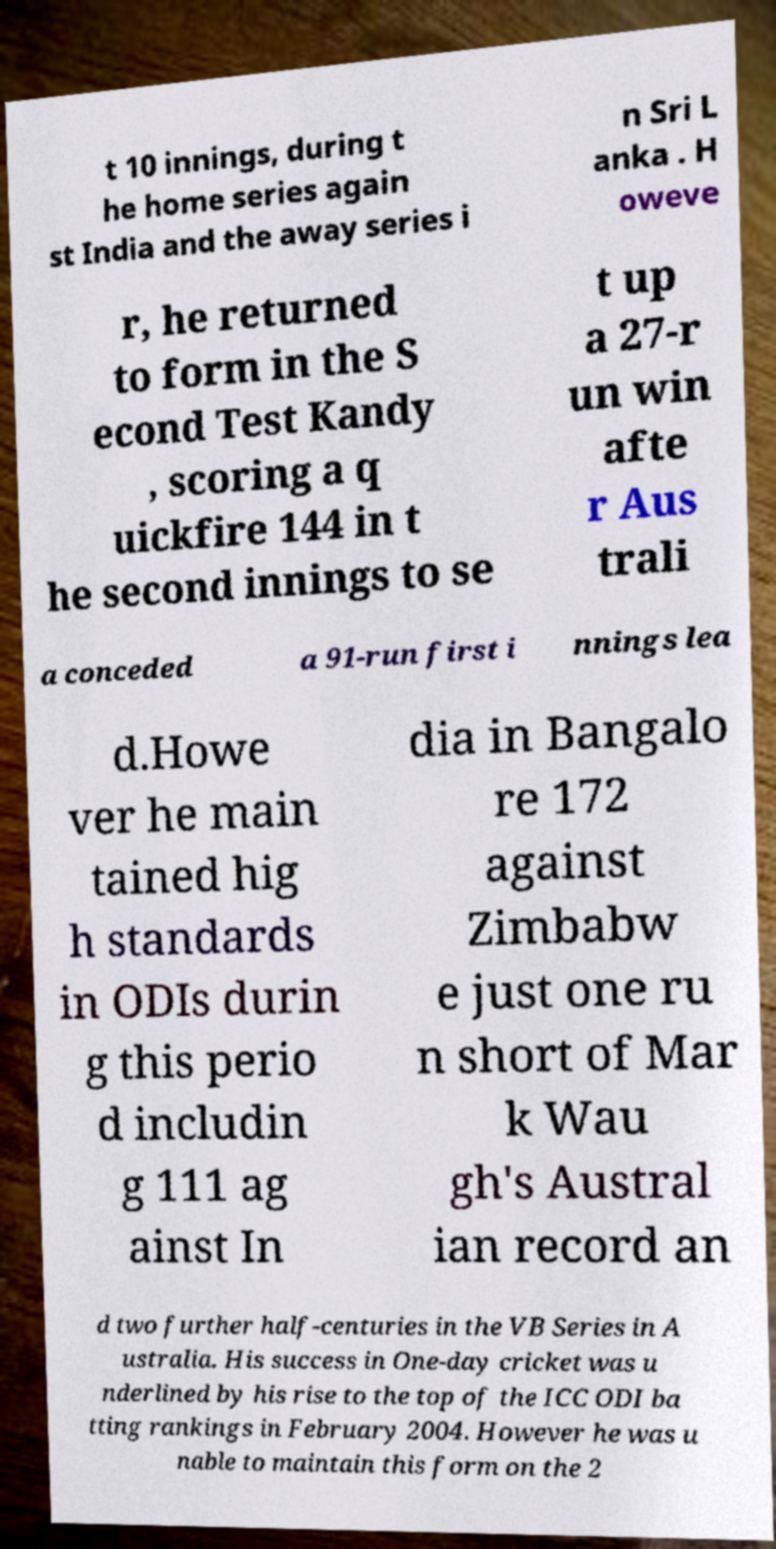Can you accurately transcribe the text from the provided image for me? t 10 innings, during t he home series again st India and the away series i n Sri L anka . H oweve r, he returned to form in the S econd Test Kandy , scoring a q uickfire 144 in t he second innings to se t up a 27-r un win afte r Aus trali a conceded a 91-run first i nnings lea d.Howe ver he main tained hig h standards in ODIs durin g this perio d includin g 111 ag ainst In dia in Bangalo re 172 against Zimbabw e just one ru n short of Mar k Wau gh's Austral ian record an d two further half-centuries in the VB Series in A ustralia. His success in One-day cricket was u nderlined by his rise to the top of the ICC ODI ba tting rankings in February 2004. However he was u nable to maintain this form on the 2 